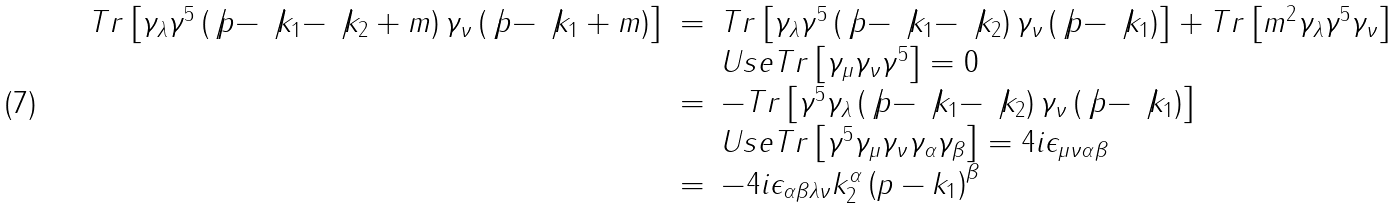<formula> <loc_0><loc_0><loc_500><loc_500>\begin{array} { r c l } T r \left [ \gamma _ { \lambda } \gamma ^ { 5 } \left ( \not p - \not k _ { 1 } - \not k _ { 2 } + m \right ) \gamma _ { \nu } \left ( \not p - \not k _ { 1 } + m \right ) \right ] & = & T r \left [ \gamma _ { \lambda } \gamma ^ { 5 } \left ( \not p - \not k _ { 1 } - \not k _ { 2 } \right ) \gamma _ { \nu } \left ( \not p - \not k _ { 1 } \right ) \right ] + T r \left [ m ^ { 2 } \gamma _ { \lambda } \gamma ^ { 5 } \gamma _ { \nu } \right ] \\ & & U s e T r \left [ \gamma _ { \mu } \gamma _ { \nu } \gamma ^ { 5 } \right ] = 0 \\ & = & - T r \left [ \gamma ^ { 5 } \gamma _ { \lambda } \left ( \not p - \not k _ { 1 } - \not k _ { 2 } \right ) \gamma _ { \nu } \left ( \not p - \not k _ { 1 } \right ) \right ] \\ & & U s e T r \left [ \gamma ^ { 5 } \gamma _ { \mu } \gamma _ { \nu } \gamma _ { \alpha } \gamma _ { \beta } \right ] = 4 i \epsilon _ { \mu \nu \alpha \beta } \\ & = & - 4 i \epsilon _ { \alpha \beta \lambda \nu } k _ { 2 } ^ { \alpha } \left ( p - k _ { 1 } \right ) ^ { \beta } \end{array}</formula> 